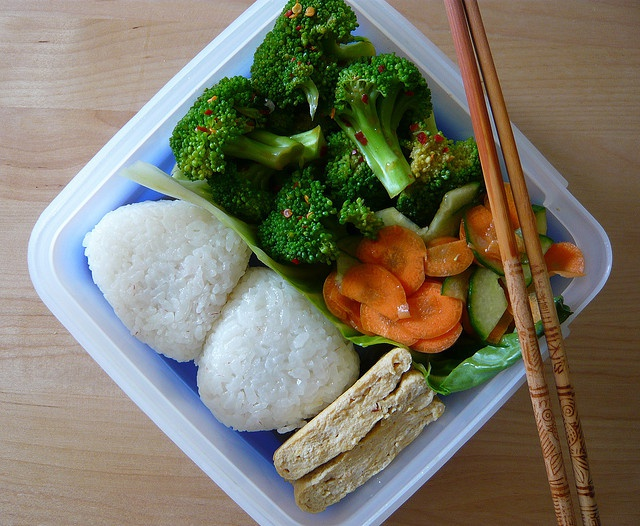Describe the objects in this image and their specific colors. I can see broccoli in darkgray, black, darkgreen, and green tones, carrot in darkgray, brown, maroon, black, and olive tones, carrot in darkgray, brown, maroon, and black tones, carrot in darkgray, brown, maroon, and red tones, and carrot in darkgray, red, maroon, and salmon tones in this image. 